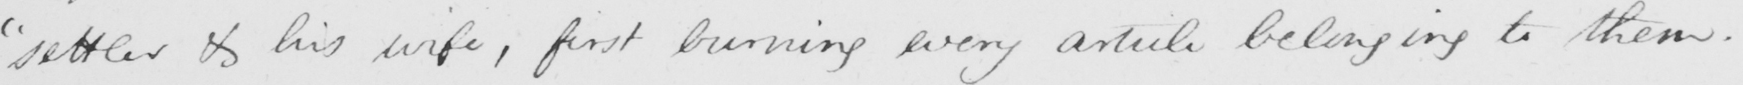Can you read and transcribe this handwriting? " settler & his wife , first burning every article belonging to them . 